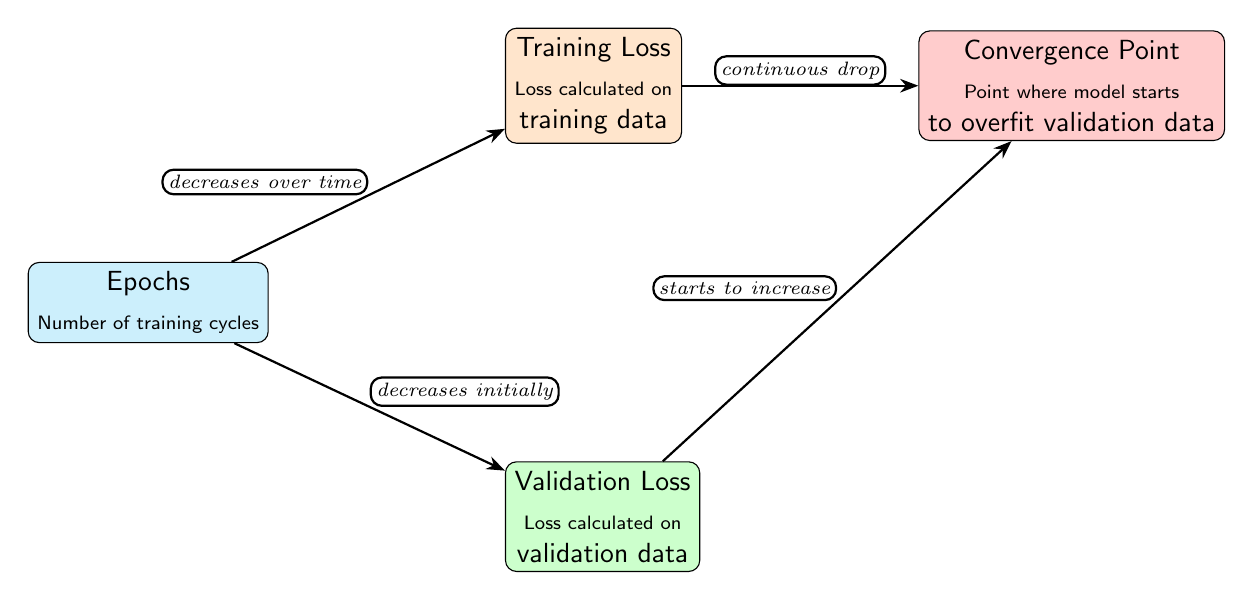What is represented on the vertical axis of the diagram? The vertical axis is not explicitly labeled in the diagram, but it represents the loss values for both training and validation. The loss values typically decrease over time for training and initially decrease for validation.
Answer: Loss values How many nodes are present in the diagram? Counting the individual entities represented, there are four nodes: Epochs, Training Loss, Validation Loss, and Convergence Point.
Answer: Four What is the relationship between epochs and training loss? The path from epochs to training loss indicates that training loss decreases over time as the model learns during training cycles, denoted by the label "decreases over time."
Answer: Decreases over time What happens to validation loss at the convergence point? At the convergence point, the validation loss is noted to start increasing, which suggests that the model begins to overfit the validation data after this point.
Answer: Starts to increase Which node is connected directly to both training loss and validation loss? The epochs node connects directly to both training loss and validation loss, indicating that both types of losses are calculated based on the number of training cycles (epochs).
Answer: Epochs What trend is observed for training loss as epochs increase? The trend noted in the diagram shows that training loss experiences a continuous drop as epochs increase, indicating improved performance on the training data.
Answer: Continuous drop What does the edge label indicate about the relationship between validation loss and the convergence point? The edge label states "starts to increase," which indicates that validation loss begins to rise right at the convergence point, implying overfitting of the model.
Answer: Starts to increase What is the effect on validation loss before reaching the convergence point? Before reaching the convergence point, the validation loss is described as decreasing initially, suggesting effective learning without overfitting during early epochs.
Answer: Decreases initially 